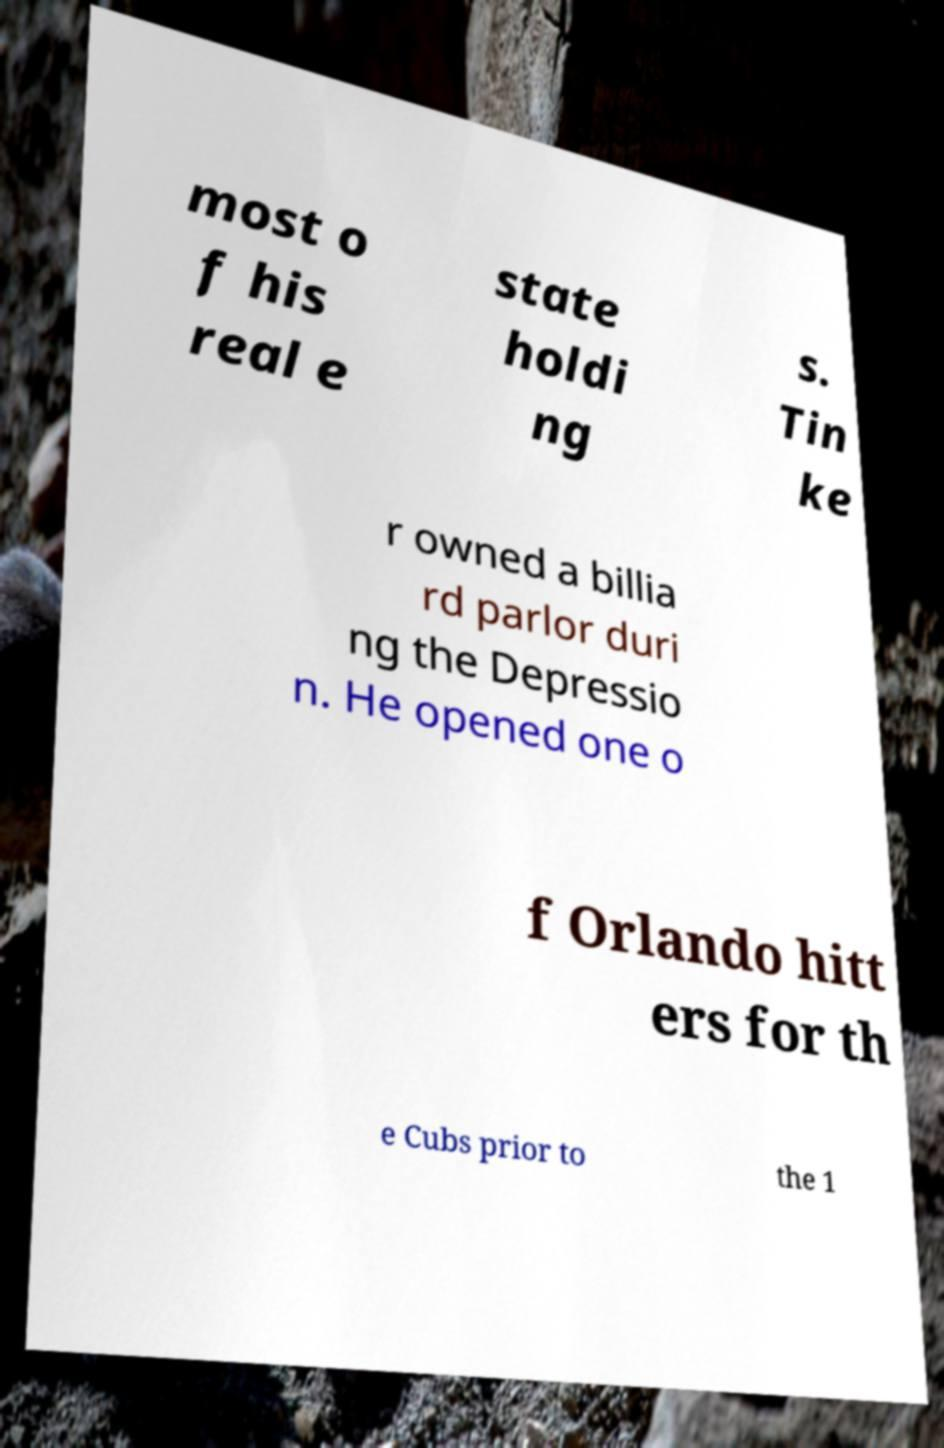Please read and relay the text visible in this image. What does it say? most o f his real e state holdi ng s. Tin ke r owned a billia rd parlor duri ng the Depressio n. He opened one o f Orlando hitt ers for th e Cubs prior to the 1 